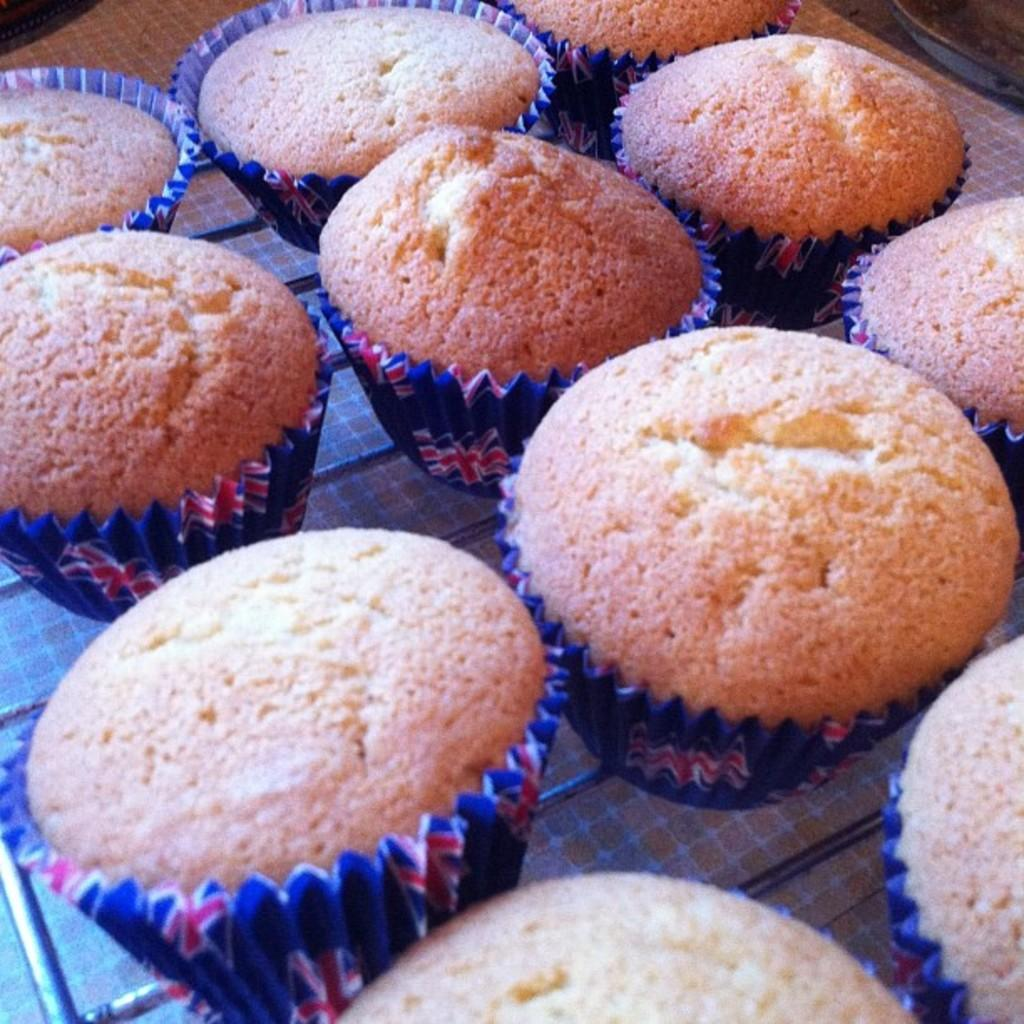What is the focus of the image? The image is zoomed in, focusing on many cupcakes in the foreground. What can be seen in the image besides the cupcakes? The image is zoomed in, so only the cupcakes are clearly visible. What are the cupcakes placed on? The cupcakes are placed on an object, but the specific object cannot be identified due to the zoomed-in perspective. What type of cave can be seen in the background of the image? There is no cave present in the image; it is focused on cupcakes in the foreground. 